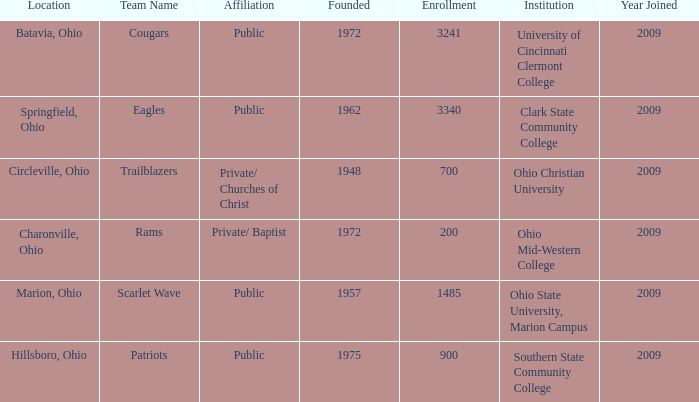What is the institution that was located is circleville, ohio? Ohio Christian University. 